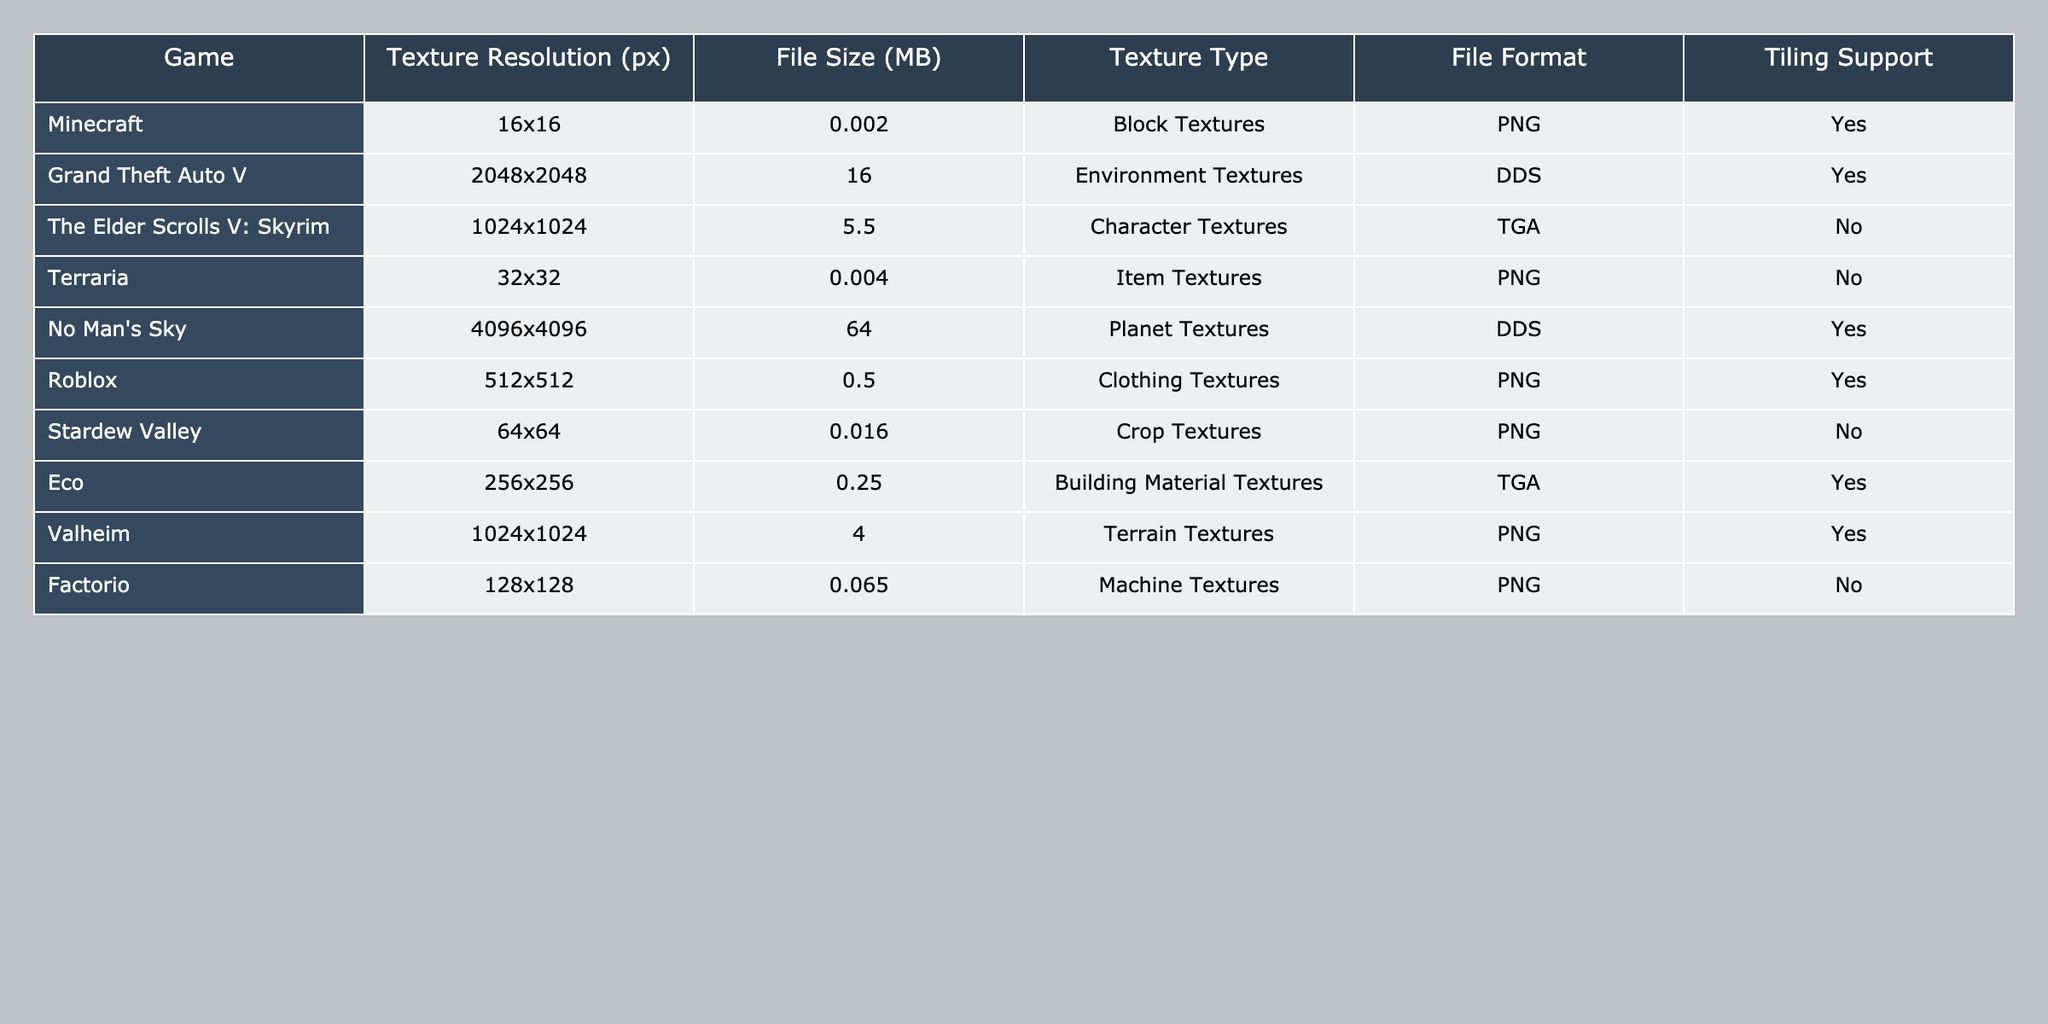What is the texture resolution of No Man's Sky? The texture resolution for No Man's Sky is listed as 4096x4096 pixels. This can be found directly in the table under the "Texture Resolution (px)" column.
Answer: 4096x4096 Which game has the largest file size for textures? By examining the "File Size (MB)" column, No Man's Sky has the largest texture file size at 64 MB, which stands out compared to the other games listed in the table.
Answer: No Man's Sky Are there any games that support tiling? The "Tiling Support" column indicates that Minecraft, Grand Theft Auto V, No Man's Sky, Roblox, and Eco support tiling, while the others do not.
Answer: Yes What is the average file size of the textures across all games listed? To find the average file size, we sum all the file sizes (0.002 + 16 + 5.5 + 0.004 + 64 + 0.5 + 0.016 + 0.25 + 4 + 0.065 = 86.337) and divide by the number of games (10). This results in an average file size of approximately 8.6337 MB.
Answer: 8.6337 Which game has the smallest texture resolution? The table shows that Minecraft has the smallest texture resolution at 16x16 pixels, making it the game with the lowest resolution in this dataset.
Answer: 16x16 Is there a game with an environment texture that supports tiling? Referring to both the "Texture Type" and "Tiling Support" columns, Grand Theft Auto V has "Environment Textures" and supports tiling, thus answering the question affirmatively.
Answer: Yes What is the difference in file size between the highest and lowest file sizes for textures? The highest file size is 64 MB (No Man's Sky) and the lowest file size is 0.002 MB (Minecraft). The difference is calculated as 64 - 0.002 = 63.998 MB.
Answer: 63.998 MB How many games have character textures in the table? Examining the "Texture Type" column, only one game, The Elder Scrolls V: Skyrim, has "Character Textures," making the answer easy to identify.
Answer: 1 